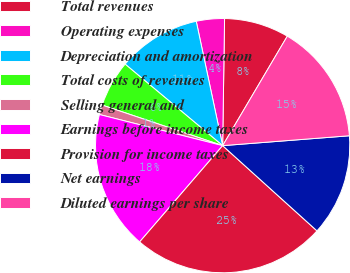<chart> <loc_0><loc_0><loc_500><loc_500><pie_chart><fcel>Total revenues<fcel>Operating expenses<fcel>Depreciation and amortization<fcel>Total costs of revenues<fcel>Selling general and<fcel>Earnings before income taxes<fcel>Provision for income taxes<fcel>Net earnings<fcel>Diluted earnings per share<nl><fcel>8.25%<fcel>3.57%<fcel>10.59%<fcel>5.91%<fcel>1.23%<fcel>17.61%<fcel>24.63%<fcel>12.93%<fcel>15.27%<nl></chart> 